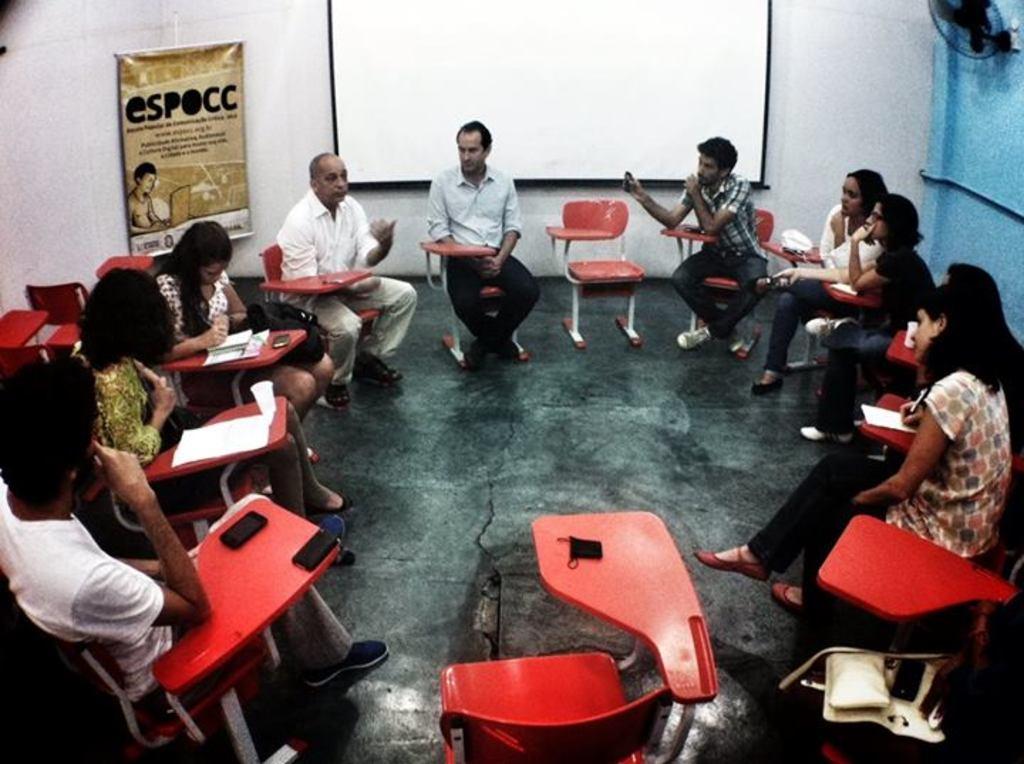How would you summarize this image in a sentence or two? In this picture we can see some persons are sitting on the chairs. This is floor. There is a banner. On the background there is a wall and this is screen. 